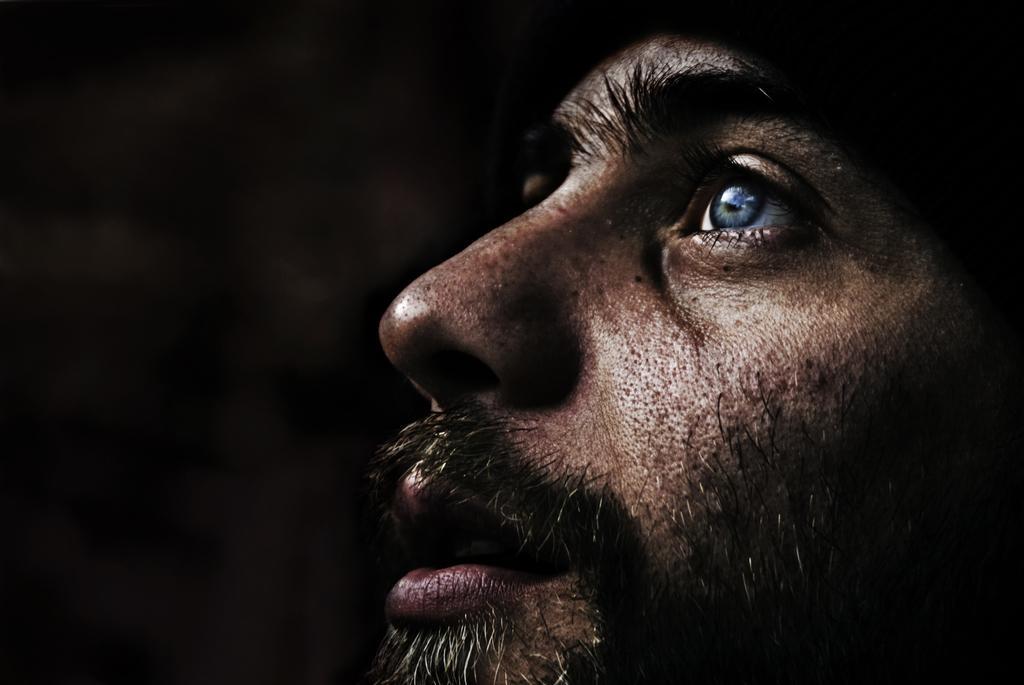How would you summarize this image in a sentence or two? In this picture there is a man. On the left it is dark. 